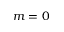Convert formula to latex. <formula><loc_0><loc_0><loc_500><loc_500>m = 0</formula> 